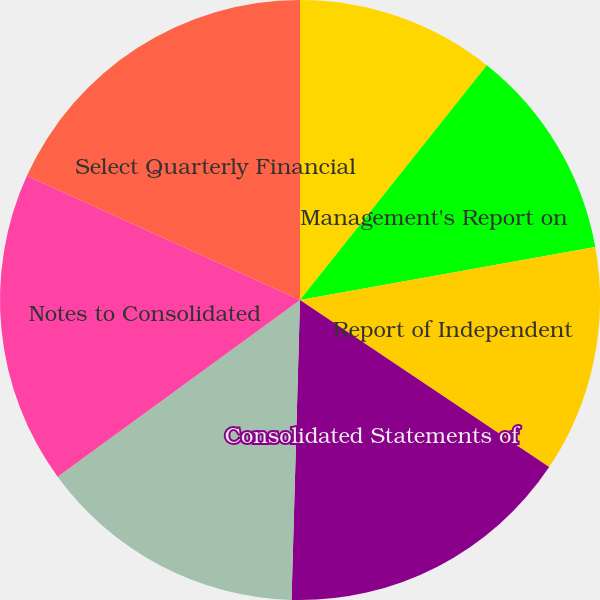Convert chart. <chart><loc_0><loc_0><loc_500><loc_500><pie_chart><fcel>Management's Responsibilities<fcel>Management's Report on<fcel>Report of Independent<fcel>Consolidated Statements of<fcel>Consolidated Balance Sheets<fcel>Notes to Consolidated<fcel>Select Quarterly Financial<nl><fcel>10.7%<fcel>11.47%<fcel>12.23%<fcel>16.05%<fcel>14.52%<fcel>16.82%<fcel>18.21%<nl></chart> 